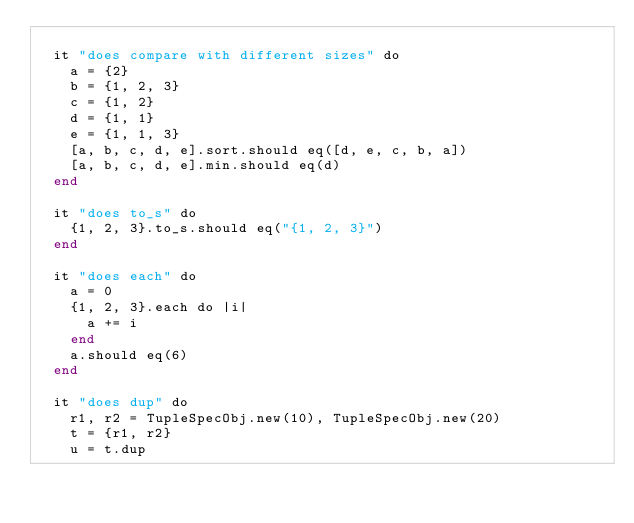Convert code to text. <code><loc_0><loc_0><loc_500><loc_500><_Crystal_>
  it "does compare with different sizes" do
    a = {2}
    b = {1, 2, 3}
    c = {1, 2}
    d = {1, 1}
    e = {1, 1, 3}
    [a, b, c, d, e].sort.should eq([d, e, c, b, a])
    [a, b, c, d, e].min.should eq(d)
  end

  it "does to_s" do
    {1, 2, 3}.to_s.should eq("{1, 2, 3}")
  end

  it "does each" do
    a = 0
    {1, 2, 3}.each do |i|
      a += i
    end
    a.should eq(6)
  end

  it "does dup" do
    r1, r2 = TupleSpecObj.new(10), TupleSpecObj.new(20)
    t = {r1, r2}
    u = t.dup</code> 